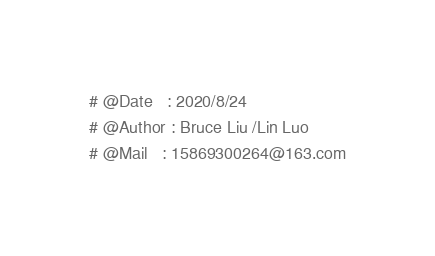Convert code to text. <code><loc_0><loc_0><loc_500><loc_500><_Python_># @Date   : 2020/8/24
# @Author : Bruce Liu /Lin Luo
# @Mail   : 15869300264@163.com
</code> 